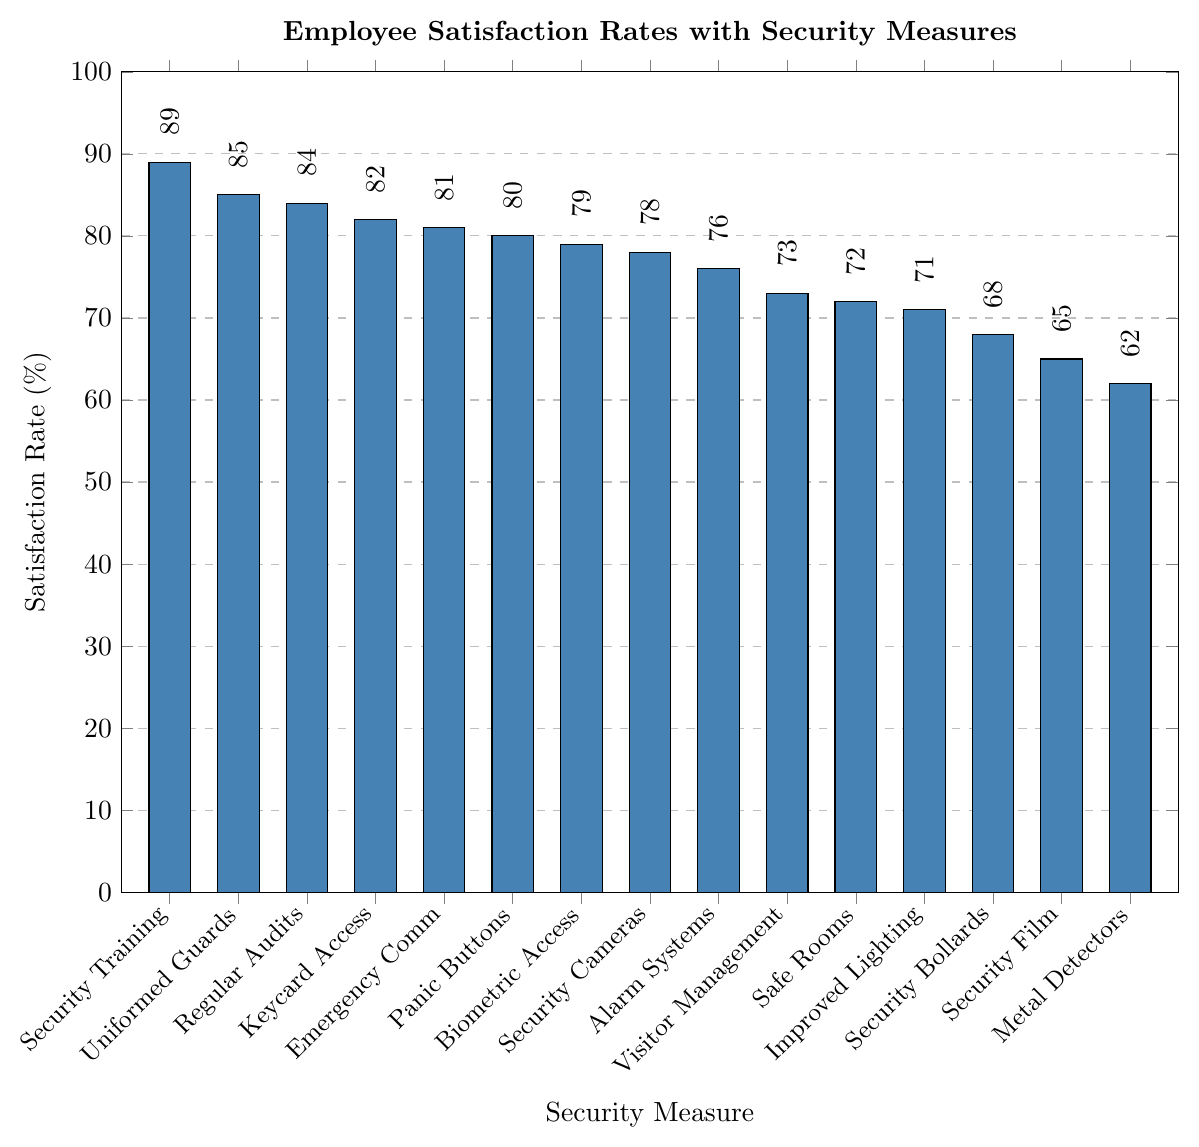Which security measure has the highest employee satisfaction rate? The highest bar in the chart corresponds to "Security Training for Employees" with a satisfaction rate.
Answer: Security Training for Employees Which two security measures have a satisfaction rate of 80% or above but less than 85%? By examining the bar heights and their corresponding values, "Keycard Access" (82%) and "Panic Buttons" (80%) meet the criteria.
Answer: Keycard Access, Panic Buttons How much higher is the satisfaction rate for Uniformed Security Guards compared to Biometric Access Control? The satisfaction rate for Uniformed Security Guards (85%) minus the rate for Biometric Access Control (79%) equals 6%.
Answer: 6% Which security measures have a satisfaction rate below 70%? The security measures with bars below the 70% line are "Metal Detectors" (62%), "Security Bollards" (68%), and "Security Window Film" (65%).
Answer: Metal Detectors, Security Bollards, Security Window Film What's the average satisfaction rate of Security Cameras, Alarm Systems, and Visitor Management Systems? Adding the rates: 78% (Security Cameras) + 76% (Alarm Systems) + 73% (Visitor Management Systems) = 227%. Dividing by 3 gives around 75.7%.
Answer: 75.7% Which two security measures have satisfaction rates closest to each other, and what are their rates? "Safe Rooms" (72%) and "Visitor Management Systems" (73%) have rates that are closest to each other, differing by only 1%.
Answer: Safe Rooms (72%), Visitor Management Systems (73%) If you were to pick security measures with satisfaction rates above the median rate, which measures would they be? First find the median rate by listing all rates in ascending order: 62%, 65%, 68%, 71%, 72%, 73%, 76%, 78%, 79%, 80%, 81%, 82%, 84%, 85%, 89%. The median (middle value) is 76%. Measures above this rate are: Security Training, Uniformed Security Guards, Regular Security Audits, Keycard Access, Emergency Communication Systems, Panic Buttons, Biometric Access Control.
Answer: Security Training, Uniformed Security Guards, Regular Security Audits, Keycard Access, Emergency Communication Systems, Panic Buttons, Biometric Access Control 